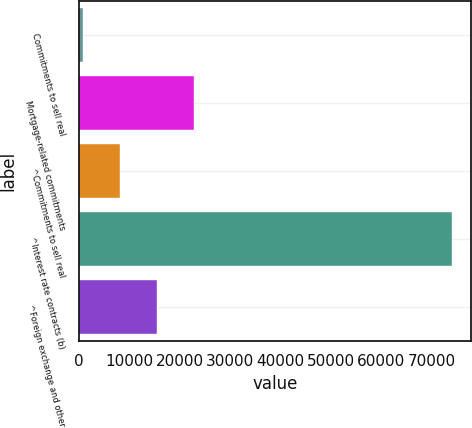Convert chart. <chart><loc_0><loc_0><loc_500><loc_500><bar_chart><fcel>Commitments to sell real<fcel>Mortgage-related commitments<fcel>^Commitments to sell real<fcel>^Interest rate contracts (b)<fcel>^Foreign exchange and other<nl><fcel>734<fcel>22763<fcel>8077<fcel>74164<fcel>15420<nl></chart> 